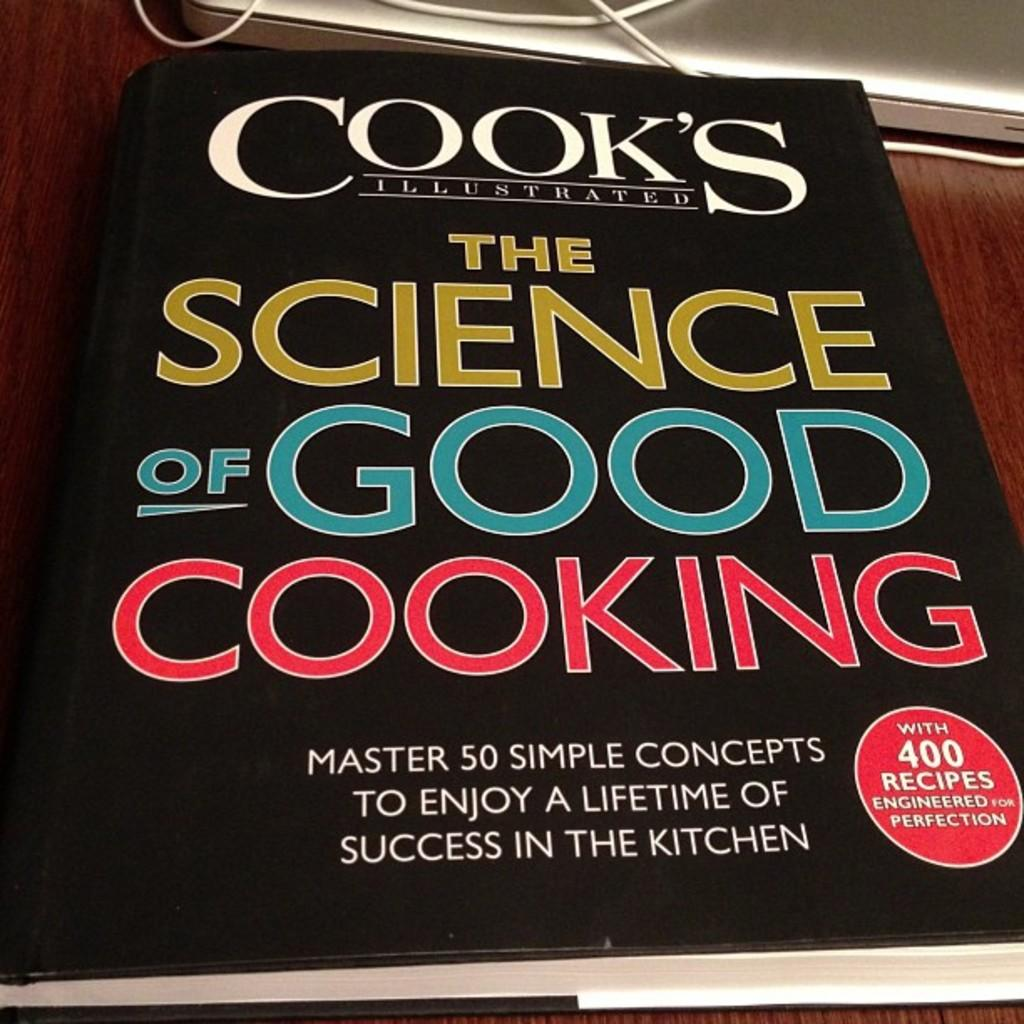<image>
Present a compact description of the photo's key features. copy of cook's illustrated the science of good cooking 